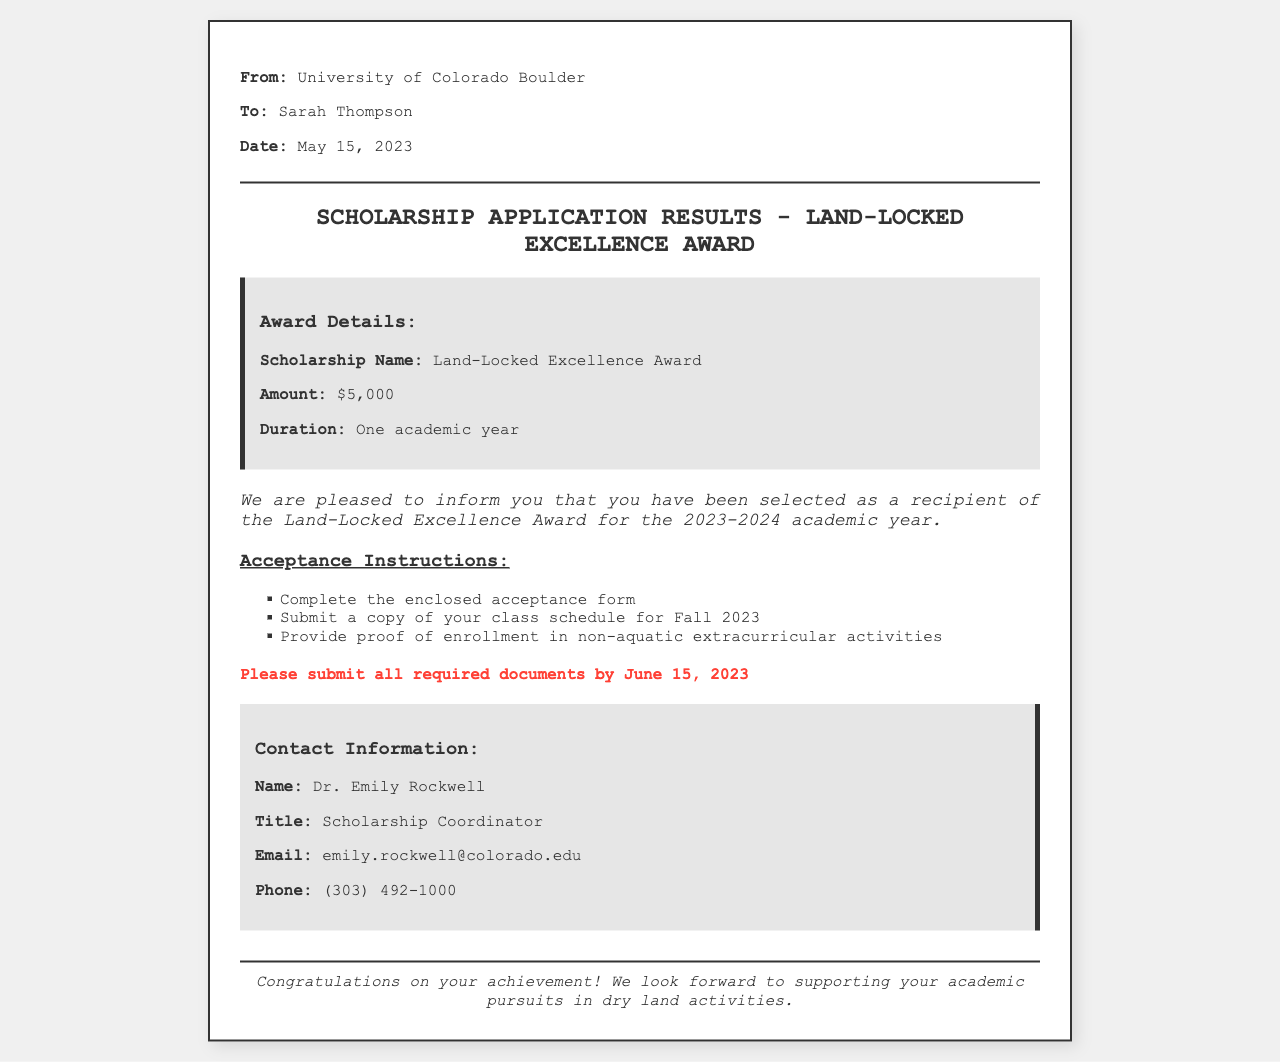What is the scholarship name? The document specifies the scholarship name as "Land-Locked Excellence Award."
Answer: Land-Locked Excellence Award What is the award amount? The award amount mentioned in the document is clearly stated.
Answer: $5,000 What is the duration of the scholarship? The document outlines the duration of the scholarship.
Answer: One academic year What is the submission deadline for required documents? The document indicates a specific deadline for submitting documents.
Answer: June 15, 2023 Who is the contact person for the scholarship? The document provides the name of the contact person responsible for the scholarship.
Answer: Dr. Emily Rockwell What type of extracurricular activities must be proven? The document requests proof of specific types of extracurricular activities.
Answer: Non-aquatic extracurricular activities How many items are required for acceptance submission? The document lists the items that need to be submitted for acceptance.
Answer: Three Why are the acceptance instructions important? Understanding these instructions is crucial for following the scholarship acceptance process.
Answer: To complete the acceptance process 